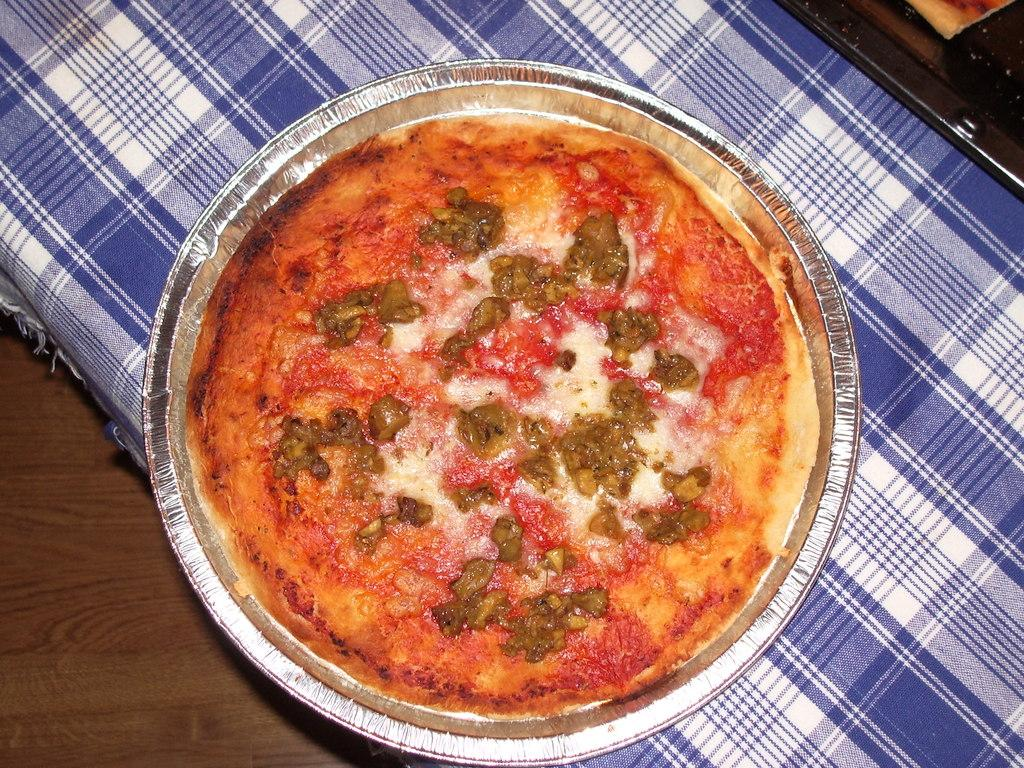What type of furniture is present in the image? There is a table in the image. What is covering the table? There is a cloth on the table. What food item can be seen on the cloth? There is a plate with pizza on the cloth. What invention is being demonstrated in the image? There is no invention being demonstrated in the image; it features a table with a cloth and pizza. How many planes can be seen in the image? There are no planes present in the image. 